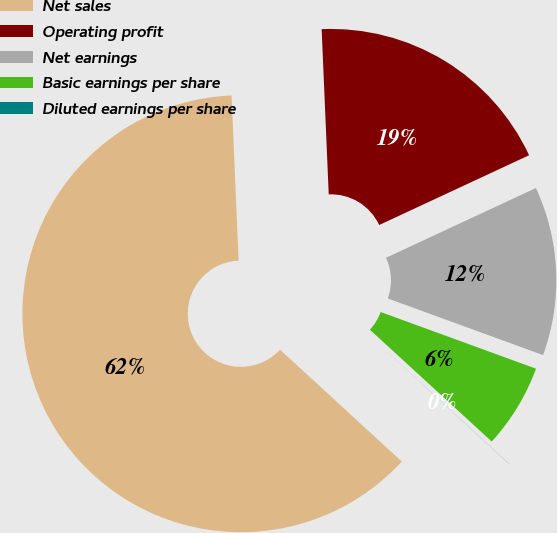Convert chart to OTSL. <chart><loc_0><loc_0><loc_500><loc_500><pie_chart><fcel>Net sales<fcel>Operating profit<fcel>Net earnings<fcel>Basic earnings per share<fcel>Diluted earnings per share<nl><fcel>62.49%<fcel>18.75%<fcel>12.5%<fcel>6.25%<fcel>0.01%<nl></chart> 